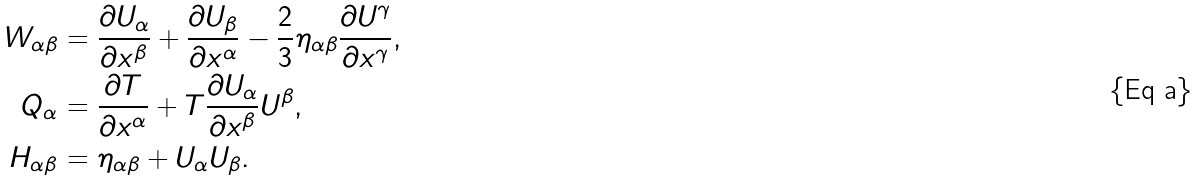<formula> <loc_0><loc_0><loc_500><loc_500>W _ { \alpha \beta } & = \frac { \partial U _ { \alpha } } { \partial x ^ { \beta } } + \frac { \partial U _ { \beta } } { \partial x ^ { \alpha } } - \frac { 2 } { 3 } \eta _ { \alpha \beta } \frac { \partial U ^ { \gamma } } { \partial x ^ { \gamma } } , \\ Q _ { \alpha } & = \frac { \partial T } { \partial x ^ { \alpha } } + T \frac { \partial U _ { \alpha } } { \partial x ^ { \beta } } U ^ { \beta } , \\ H _ { \alpha \beta } & = \eta _ { \alpha \beta } + U _ { \alpha } U _ { \beta } .</formula> 